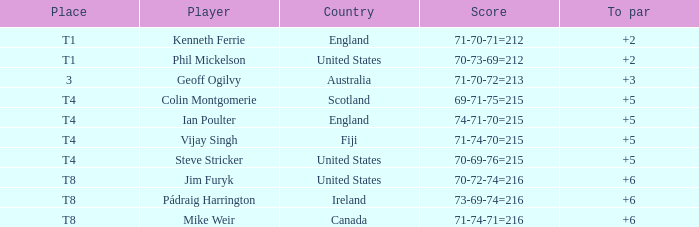What score to highest to par did Mike Weir achieve? 6.0. 